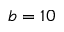<formula> <loc_0><loc_0><loc_500><loc_500>b = 1 0</formula> 